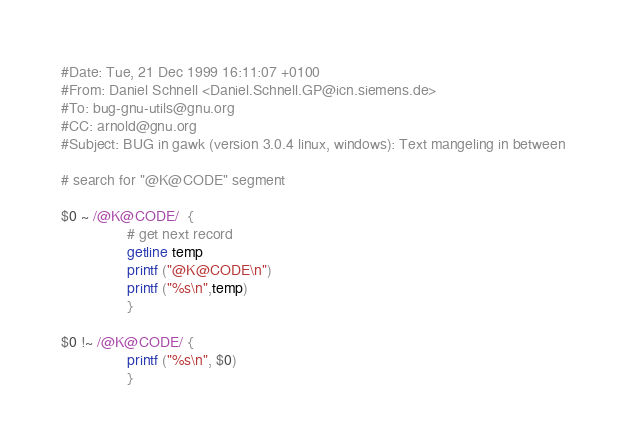Convert code to text. <code><loc_0><loc_0><loc_500><loc_500><_Awk_>#Date: Tue, 21 Dec 1999 16:11:07 +0100
#From: Daniel Schnell <Daniel.Schnell.GP@icn.siemens.de>
#To: bug-gnu-utils@gnu.org
#CC: arnold@gnu.org
#Subject: BUG in gawk (version 3.0.4 linux, windows): Text mangeling in between

# search for "@K@CODE" segment

$0 ~ /@K@CODE/  {
                # get next record
                getline temp
                printf ("@K@CODE\n")
                printf ("%s\n",temp)
                }

$0 !~ /@K@CODE/ {
                printf ("%s\n", $0)
                }
</code> 